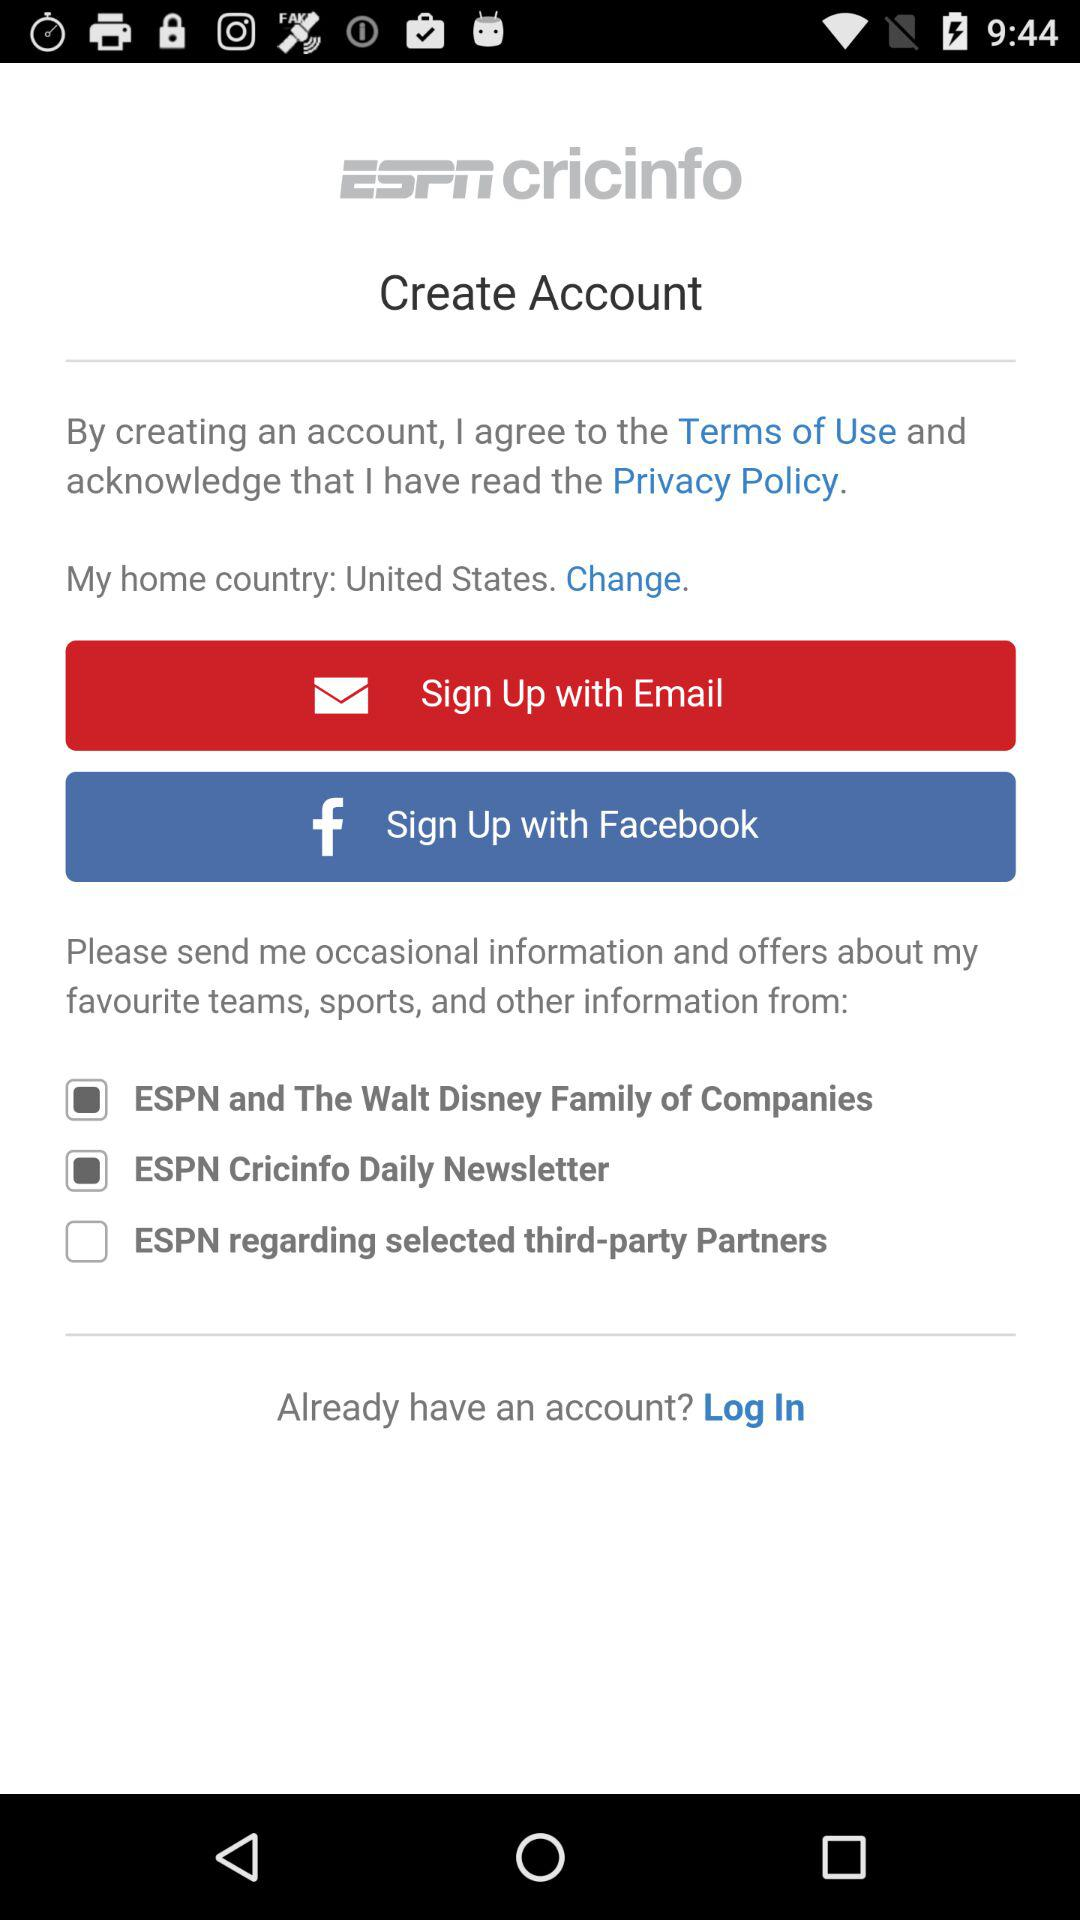What are the sign up options? The sign up options are :"Email" and "Facebook". 